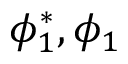Convert formula to latex. <formula><loc_0><loc_0><loc_500><loc_500>\phi _ { 1 } ^ { * } , \phi _ { 1 }</formula> 